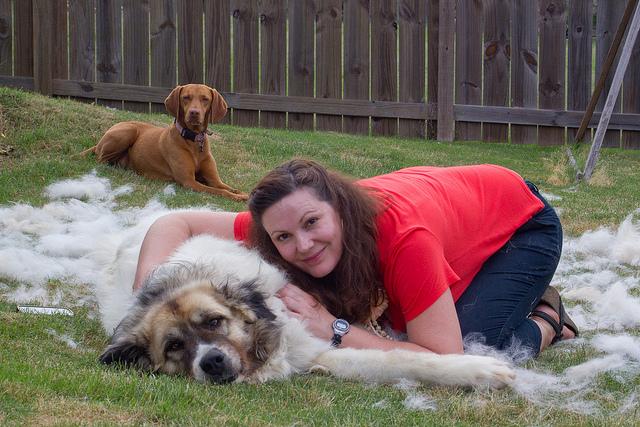Is the dog doing his job?
Quick response, please. Yes. Does the woman have bangs?
Quick response, please. No. What is the dog's breed?
Keep it brief. Lab. Is the second dog angry?
Give a very brief answer. No. What has just been done to this dog?
Answer briefly. Shaved. 